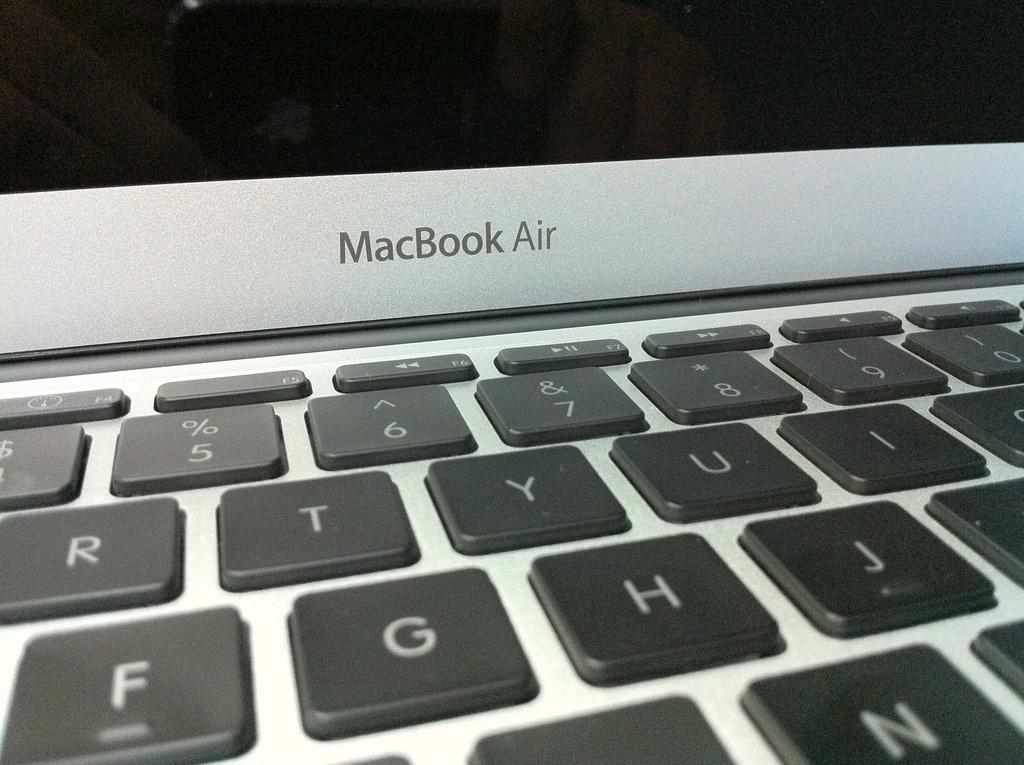<image>
Give a short and clear explanation of the subsequent image. Picture of Mac book Air with keyboard and screen 